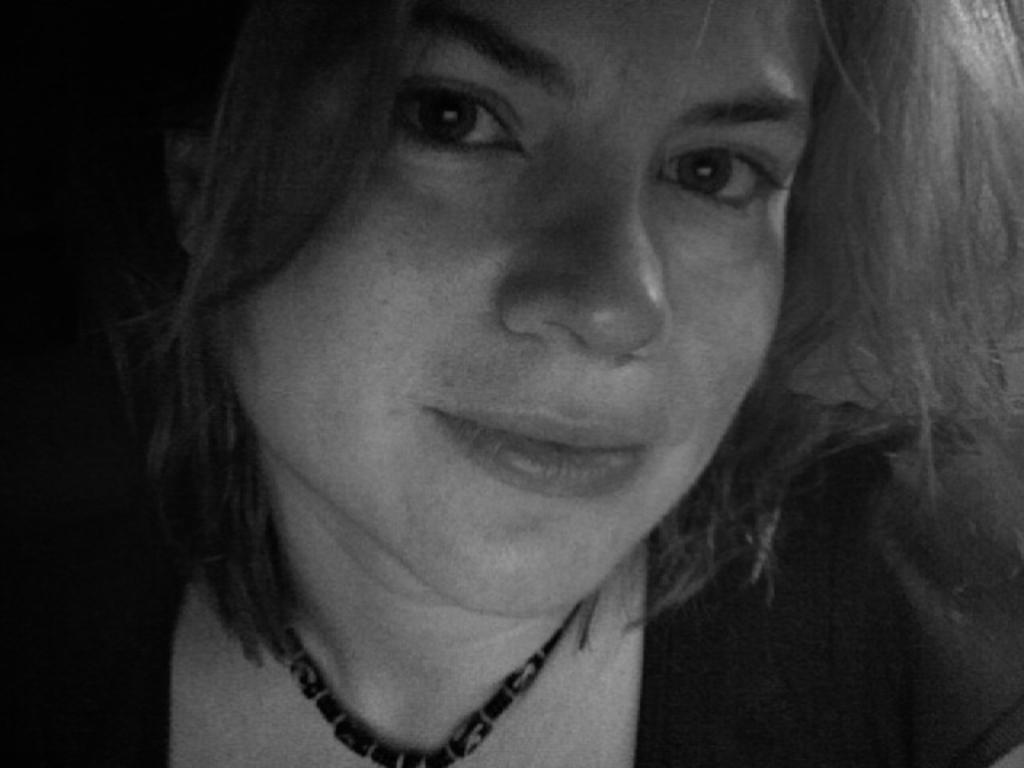What is the main subject in the foreground of the image? There is a person in the foreground of the image. Can you describe any accessories the person is wearing? The person is wearing a necklace. What type of sail can be seen on the turkey in the image? There is no sail or turkey present in the image; it only features a person wearing a necklace. 